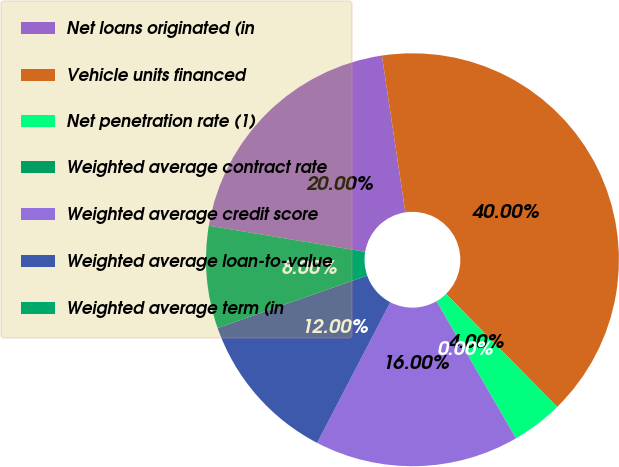Convert chart. <chart><loc_0><loc_0><loc_500><loc_500><pie_chart><fcel>Net loans originated (in<fcel>Vehicle units financed<fcel>Net penetration rate (1)<fcel>Weighted average contract rate<fcel>Weighted average credit score<fcel>Weighted average loan-to-value<fcel>Weighted average term (in<nl><fcel>20.0%<fcel>40.0%<fcel>4.0%<fcel>0.0%<fcel>16.0%<fcel>12.0%<fcel>8.0%<nl></chart> 